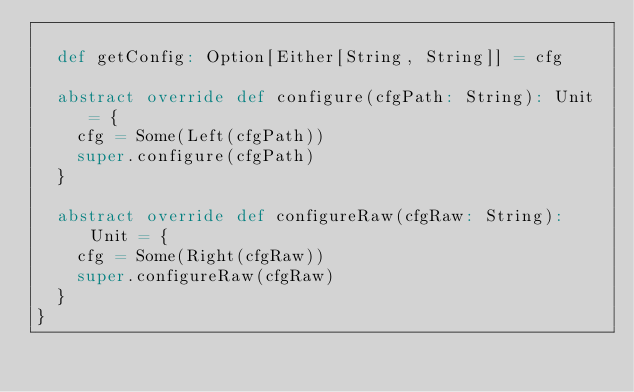<code> <loc_0><loc_0><loc_500><loc_500><_Scala_>
  def getConfig: Option[Either[String, String]] = cfg

  abstract override def configure(cfgPath: String): Unit = {
    cfg = Some(Left(cfgPath))
    super.configure(cfgPath)
  }

  abstract override def configureRaw(cfgRaw: String): Unit = {
    cfg = Some(Right(cfgRaw))
    super.configureRaw(cfgRaw)
  }
}</code> 